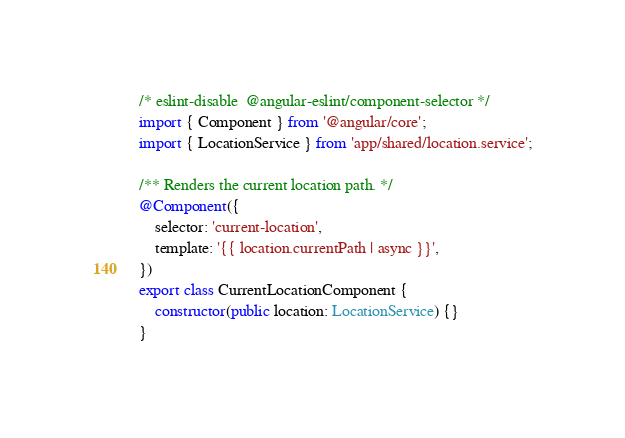<code> <loc_0><loc_0><loc_500><loc_500><_TypeScript_>/* eslint-disable  @angular-eslint/component-selector */
import { Component } from '@angular/core';
import { LocationService } from 'app/shared/location.service';

/** Renders the current location path. */
@Component({
    selector: 'current-location',
    template: '{{ location.currentPath | async }}',
})
export class CurrentLocationComponent {
    constructor(public location: LocationService) {}
}
</code> 